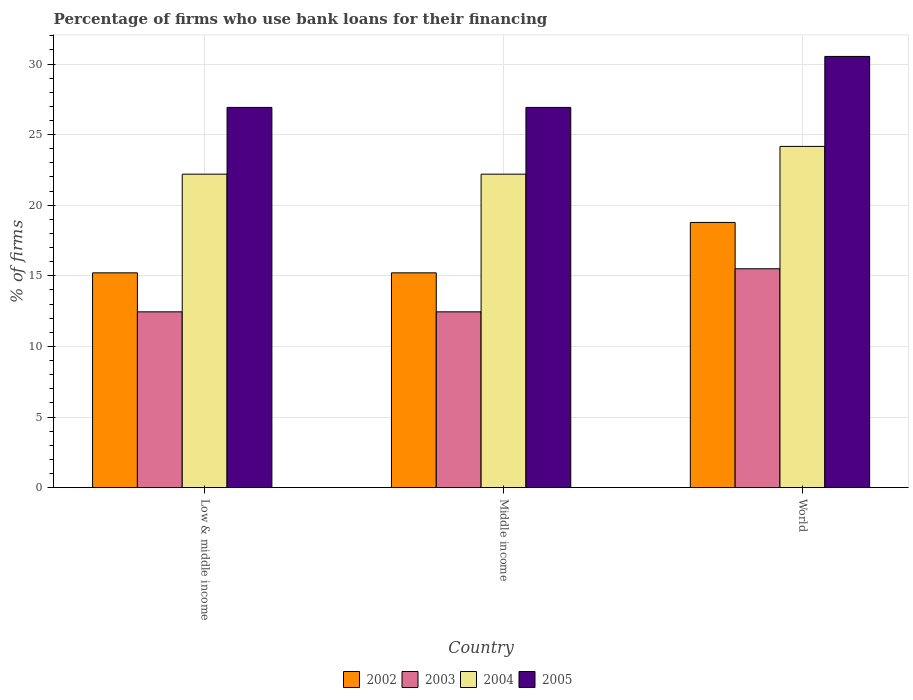How many different coloured bars are there?
Your answer should be very brief. 4. How many groups of bars are there?
Provide a short and direct response. 3. Are the number of bars per tick equal to the number of legend labels?
Your response must be concise. Yes. What is the percentage of firms who use bank loans for their financing in 2002 in Low & middle income?
Make the answer very short. 15.21. Across all countries, what is the maximum percentage of firms who use bank loans for their financing in 2005?
Make the answer very short. 30.54. Across all countries, what is the minimum percentage of firms who use bank loans for their financing in 2002?
Your answer should be very brief. 15.21. In which country was the percentage of firms who use bank loans for their financing in 2004 minimum?
Provide a succinct answer. Low & middle income. What is the total percentage of firms who use bank loans for their financing in 2005 in the graph?
Ensure brevity in your answer.  84.39. What is the difference between the percentage of firms who use bank loans for their financing in 2004 in Low & middle income and that in Middle income?
Your response must be concise. 0. What is the difference between the percentage of firms who use bank loans for their financing in 2004 in Low & middle income and the percentage of firms who use bank loans for their financing in 2002 in Middle income?
Your response must be concise. 6.99. What is the average percentage of firms who use bank loans for their financing in 2003 per country?
Offer a very short reply. 13.47. What is the difference between the percentage of firms who use bank loans for their financing of/in 2005 and percentage of firms who use bank loans for their financing of/in 2004 in Low & middle income?
Provide a succinct answer. 4.73. What is the ratio of the percentage of firms who use bank loans for their financing in 2002 in Low & middle income to that in Middle income?
Provide a short and direct response. 1. Is the percentage of firms who use bank loans for their financing in 2002 in Low & middle income less than that in Middle income?
Your response must be concise. No. Is the difference between the percentage of firms who use bank loans for their financing in 2005 in Middle income and World greater than the difference between the percentage of firms who use bank loans for their financing in 2004 in Middle income and World?
Keep it short and to the point. No. What is the difference between the highest and the second highest percentage of firms who use bank loans for their financing in 2002?
Your answer should be compact. 3.57. What is the difference between the highest and the lowest percentage of firms who use bank loans for their financing in 2002?
Your answer should be very brief. 3.57. Is the sum of the percentage of firms who use bank loans for their financing in 2003 in Low & middle income and World greater than the maximum percentage of firms who use bank loans for their financing in 2002 across all countries?
Provide a short and direct response. Yes. Is it the case that in every country, the sum of the percentage of firms who use bank loans for their financing in 2003 and percentage of firms who use bank loans for their financing in 2002 is greater than the sum of percentage of firms who use bank loans for their financing in 2005 and percentage of firms who use bank loans for their financing in 2004?
Your response must be concise. No. What does the 4th bar from the right in Low & middle income represents?
Offer a terse response. 2002. Is it the case that in every country, the sum of the percentage of firms who use bank loans for their financing in 2002 and percentage of firms who use bank loans for their financing in 2004 is greater than the percentage of firms who use bank loans for their financing in 2003?
Provide a succinct answer. Yes. Are all the bars in the graph horizontal?
Ensure brevity in your answer.  No. What is the difference between two consecutive major ticks on the Y-axis?
Make the answer very short. 5. Are the values on the major ticks of Y-axis written in scientific E-notation?
Your response must be concise. No. Does the graph contain any zero values?
Offer a terse response. No. Where does the legend appear in the graph?
Your answer should be compact. Bottom center. What is the title of the graph?
Provide a short and direct response. Percentage of firms who use bank loans for their financing. Does "1994" appear as one of the legend labels in the graph?
Offer a very short reply. No. What is the label or title of the Y-axis?
Your answer should be compact. % of firms. What is the % of firms of 2002 in Low & middle income?
Offer a very short reply. 15.21. What is the % of firms in 2003 in Low & middle income?
Give a very brief answer. 12.45. What is the % of firms in 2005 in Low & middle income?
Your answer should be very brief. 26.93. What is the % of firms in 2002 in Middle income?
Ensure brevity in your answer.  15.21. What is the % of firms in 2003 in Middle income?
Your answer should be very brief. 12.45. What is the % of firms in 2005 in Middle income?
Offer a very short reply. 26.93. What is the % of firms of 2002 in World?
Make the answer very short. 18.78. What is the % of firms in 2003 in World?
Make the answer very short. 15.5. What is the % of firms of 2004 in World?
Your answer should be compact. 24.17. What is the % of firms in 2005 in World?
Offer a very short reply. 30.54. Across all countries, what is the maximum % of firms of 2002?
Offer a terse response. 18.78. Across all countries, what is the maximum % of firms of 2003?
Keep it short and to the point. 15.5. Across all countries, what is the maximum % of firms of 2004?
Make the answer very short. 24.17. Across all countries, what is the maximum % of firms of 2005?
Provide a succinct answer. 30.54. Across all countries, what is the minimum % of firms of 2002?
Make the answer very short. 15.21. Across all countries, what is the minimum % of firms in 2003?
Provide a short and direct response. 12.45. Across all countries, what is the minimum % of firms in 2005?
Offer a very short reply. 26.93. What is the total % of firms of 2002 in the graph?
Provide a succinct answer. 49.21. What is the total % of firms of 2003 in the graph?
Make the answer very short. 40.4. What is the total % of firms in 2004 in the graph?
Your answer should be compact. 68.57. What is the total % of firms in 2005 in the graph?
Make the answer very short. 84.39. What is the difference between the % of firms in 2002 in Low & middle income and that in Middle income?
Give a very brief answer. 0. What is the difference between the % of firms of 2004 in Low & middle income and that in Middle income?
Ensure brevity in your answer.  0. What is the difference between the % of firms in 2002 in Low & middle income and that in World?
Provide a short and direct response. -3.57. What is the difference between the % of firms of 2003 in Low & middle income and that in World?
Give a very brief answer. -3.05. What is the difference between the % of firms in 2004 in Low & middle income and that in World?
Offer a terse response. -1.97. What is the difference between the % of firms of 2005 in Low & middle income and that in World?
Your response must be concise. -3.61. What is the difference between the % of firms of 2002 in Middle income and that in World?
Your response must be concise. -3.57. What is the difference between the % of firms in 2003 in Middle income and that in World?
Make the answer very short. -3.05. What is the difference between the % of firms of 2004 in Middle income and that in World?
Make the answer very short. -1.97. What is the difference between the % of firms of 2005 in Middle income and that in World?
Your answer should be very brief. -3.61. What is the difference between the % of firms in 2002 in Low & middle income and the % of firms in 2003 in Middle income?
Keep it short and to the point. 2.76. What is the difference between the % of firms of 2002 in Low & middle income and the % of firms of 2004 in Middle income?
Make the answer very short. -6.99. What is the difference between the % of firms in 2002 in Low & middle income and the % of firms in 2005 in Middle income?
Provide a succinct answer. -11.72. What is the difference between the % of firms of 2003 in Low & middle income and the % of firms of 2004 in Middle income?
Make the answer very short. -9.75. What is the difference between the % of firms of 2003 in Low & middle income and the % of firms of 2005 in Middle income?
Provide a short and direct response. -14.48. What is the difference between the % of firms in 2004 in Low & middle income and the % of firms in 2005 in Middle income?
Provide a short and direct response. -4.73. What is the difference between the % of firms of 2002 in Low & middle income and the % of firms of 2003 in World?
Provide a succinct answer. -0.29. What is the difference between the % of firms of 2002 in Low & middle income and the % of firms of 2004 in World?
Ensure brevity in your answer.  -8.95. What is the difference between the % of firms of 2002 in Low & middle income and the % of firms of 2005 in World?
Offer a terse response. -15.33. What is the difference between the % of firms in 2003 in Low & middle income and the % of firms in 2004 in World?
Your answer should be very brief. -11.72. What is the difference between the % of firms in 2003 in Low & middle income and the % of firms in 2005 in World?
Your response must be concise. -18.09. What is the difference between the % of firms in 2004 in Low & middle income and the % of firms in 2005 in World?
Keep it short and to the point. -8.34. What is the difference between the % of firms of 2002 in Middle income and the % of firms of 2003 in World?
Provide a succinct answer. -0.29. What is the difference between the % of firms of 2002 in Middle income and the % of firms of 2004 in World?
Your answer should be very brief. -8.95. What is the difference between the % of firms of 2002 in Middle income and the % of firms of 2005 in World?
Your answer should be very brief. -15.33. What is the difference between the % of firms in 2003 in Middle income and the % of firms in 2004 in World?
Ensure brevity in your answer.  -11.72. What is the difference between the % of firms in 2003 in Middle income and the % of firms in 2005 in World?
Offer a very short reply. -18.09. What is the difference between the % of firms in 2004 in Middle income and the % of firms in 2005 in World?
Give a very brief answer. -8.34. What is the average % of firms of 2002 per country?
Offer a terse response. 16.4. What is the average % of firms in 2003 per country?
Provide a short and direct response. 13.47. What is the average % of firms of 2004 per country?
Offer a terse response. 22.86. What is the average % of firms in 2005 per country?
Keep it short and to the point. 28.13. What is the difference between the % of firms of 2002 and % of firms of 2003 in Low & middle income?
Provide a succinct answer. 2.76. What is the difference between the % of firms of 2002 and % of firms of 2004 in Low & middle income?
Offer a terse response. -6.99. What is the difference between the % of firms of 2002 and % of firms of 2005 in Low & middle income?
Your response must be concise. -11.72. What is the difference between the % of firms of 2003 and % of firms of 2004 in Low & middle income?
Offer a very short reply. -9.75. What is the difference between the % of firms of 2003 and % of firms of 2005 in Low & middle income?
Provide a succinct answer. -14.48. What is the difference between the % of firms of 2004 and % of firms of 2005 in Low & middle income?
Provide a succinct answer. -4.73. What is the difference between the % of firms of 2002 and % of firms of 2003 in Middle income?
Make the answer very short. 2.76. What is the difference between the % of firms in 2002 and % of firms in 2004 in Middle income?
Your response must be concise. -6.99. What is the difference between the % of firms in 2002 and % of firms in 2005 in Middle income?
Give a very brief answer. -11.72. What is the difference between the % of firms in 2003 and % of firms in 2004 in Middle income?
Offer a terse response. -9.75. What is the difference between the % of firms of 2003 and % of firms of 2005 in Middle income?
Keep it short and to the point. -14.48. What is the difference between the % of firms in 2004 and % of firms in 2005 in Middle income?
Give a very brief answer. -4.73. What is the difference between the % of firms in 2002 and % of firms in 2003 in World?
Offer a very short reply. 3.28. What is the difference between the % of firms of 2002 and % of firms of 2004 in World?
Keep it short and to the point. -5.39. What is the difference between the % of firms of 2002 and % of firms of 2005 in World?
Your answer should be very brief. -11.76. What is the difference between the % of firms in 2003 and % of firms in 2004 in World?
Your answer should be compact. -8.67. What is the difference between the % of firms in 2003 and % of firms in 2005 in World?
Your response must be concise. -15.04. What is the difference between the % of firms in 2004 and % of firms in 2005 in World?
Your answer should be compact. -6.37. What is the ratio of the % of firms of 2004 in Low & middle income to that in Middle income?
Give a very brief answer. 1. What is the ratio of the % of firms of 2002 in Low & middle income to that in World?
Your answer should be very brief. 0.81. What is the ratio of the % of firms of 2003 in Low & middle income to that in World?
Provide a succinct answer. 0.8. What is the ratio of the % of firms in 2004 in Low & middle income to that in World?
Your response must be concise. 0.92. What is the ratio of the % of firms of 2005 in Low & middle income to that in World?
Keep it short and to the point. 0.88. What is the ratio of the % of firms of 2002 in Middle income to that in World?
Keep it short and to the point. 0.81. What is the ratio of the % of firms in 2003 in Middle income to that in World?
Give a very brief answer. 0.8. What is the ratio of the % of firms of 2004 in Middle income to that in World?
Your answer should be very brief. 0.92. What is the ratio of the % of firms in 2005 in Middle income to that in World?
Offer a terse response. 0.88. What is the difference between the highest and the second highest % of firms of 2002?
Ensure brevity in your answer.  3.57. What is the difference between the highest and the second highest % of firms in 2003?
Offer a very short reply. 3.05. What is the difference between the highest and the second highest % of firms in 2004?
Give a very brief answer. 1.97. What is the difference between the highest and the second highest % of firms in 2005?
Your answer should be very brief. 3.61. What is the difference between the highest and the lowest % of firms in 2002?
Your response must be concise. 3.57. What is the difference between the highest and the lowest % of firms of 2003?
Make the answer very short. 3.05. What is the difference between the highest and the lowest % of firms in 2004?
Provide a succinct answer. 1.97. What is the difference between the highest and the lowest % of firms in 2005?
Give a very brief answer. 3.61. 